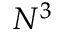<formula> <loc_0><loc_0><loc_500><loc_500>N ^ { 3 }</formula> 